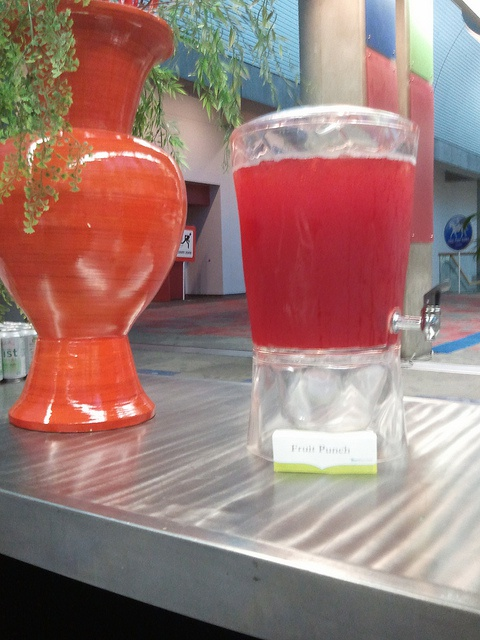Describe the objects in this image and their specific colors. I can see dining table in olive, gray, darkgray, and lightgray tones, cup in olive, brown, lightgray, and darkgray tones, and vase in olive, red, brown, and salmon tones in this image. 